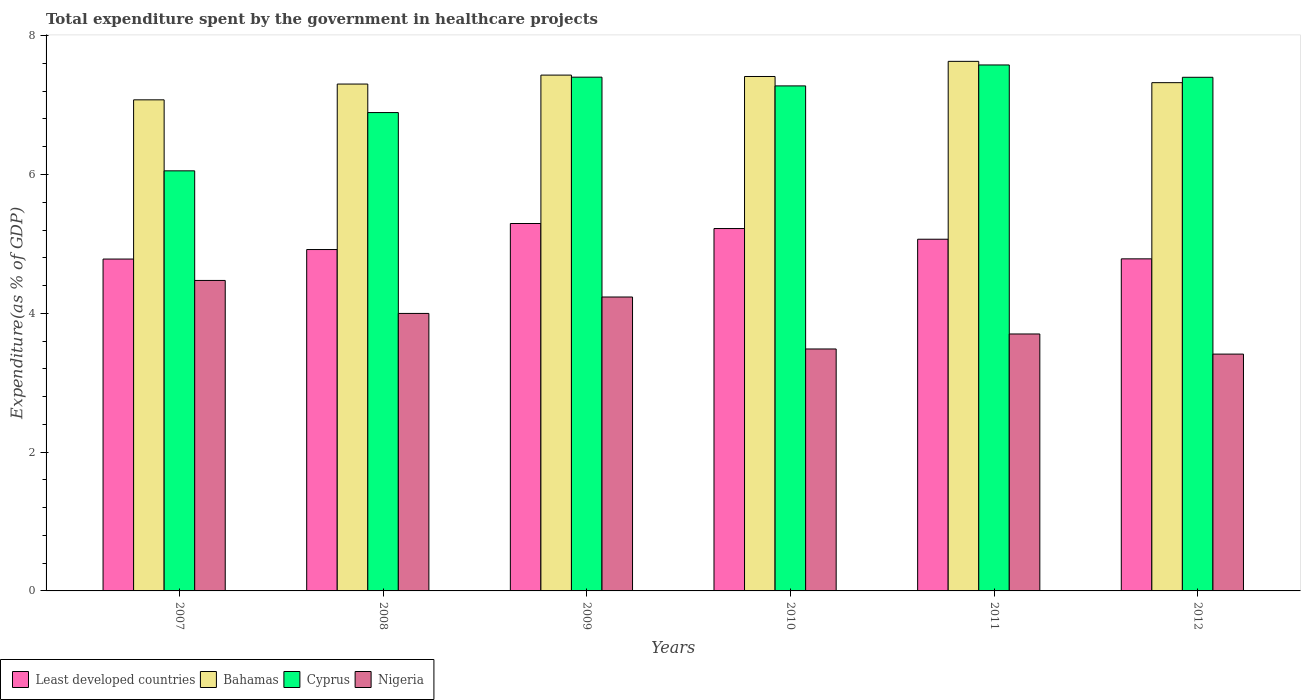How many different coloured bars are there?
Offer a very short reply. 4. How many bars are there on the 2nd tick from the right?
Give a very brief answer. 4. What is the label of the 6th group of bars from the left?
Ensure brevity in your answer.  2012. In how many cases, is the number of bars for a given year not equal to the number of legend labels?
Keep it short and to the point. 0. What is the total expenditure spent by the government in healthcare projects in Cyprus in 2010?
Ensure brevity in your answer.  7.28. Across all years, what is the maximum total expenditure spent by the government in healthcare projects in Nigeria?
Offer a terse response. 4.47. Across all years, what is the minimum total expenditure spent by the government in healthcare projects in Cyprus?
Your response must be concise. 6.05. In which year was the total expenditure spent by the government in healthcare projects in Least developed countries maximum?
Your answer should be very brief. 2009. In which year was the total expenditure spent by the government in healthcare projects in Cyprus minimum?
Offer a very short reply. 2007. What is the total total expenditure spent by the government in healthcare projects in Least developed countries in the graph?
Make the answer very short. 30.07. What is the difference between the total expenditure spent by the government in healthcare projects in Least developed countries in 2009 and that in 2010?
Offer a very short reply. 0.07. What is the difference between the total expenditure spent by the government in healthcare projects in Bahamas in 2007 and the total expenditure spent by the government in healthcare projects in Nigeria in 2012?
Ensure brevity in your answer.  3.66. What is the average total expenditure spent by the government in healthcare projects in Bahamas per year?
Keep it short and to the point. 7.36. In the year 2010, what is the difference between the total expenditure spent by the government in healthcare projects in Cyprus and total expenditure spent by the government in healthcare projects in Least developed countries?
Your answer should be very brief. 2.06. In how many years, is the total expenditure spent by the government in healthcare projects in Least developed countries greater than 2.4 %?
Offer a very short reply. 6. What is the ratio of the total expenditure spent by the government in healthcare projects in Bahamas in 2008 to that in 2012?
Give a very brief answer. 1. Is the total expenditure spent by the government in healthcare projects in Least developed countries in 2010 less than that in 2012?
Keep it short and to the point. No. What is the difference between the highest and the second highest total expenditure spent by the government in healthcare projects in Bahamas?
Your answer should be compact. 0.2. What is the difference between the highest and the lowest total expenditure spent by the government in healthcare projects in Bahamas?
Keep it short and to the point. 0.55. What does the 4th bar from the left in 2009 represents?
Provide a short and direct response. Nigeria. What does the 1st bar from the right in 2010 represents?
Give a very brief answer. Nigeria. Is it the case that in every year, the sum of the total expenditure spent by the government in healthcare projects in Nigeria and total expenditure spent by the government in healthcare projects in Cyprus is greater than the total expenditure spent by the government in healthcare projects in Bahamas?
Give a very brief answer. Yes. Are all the bars in the graph horizontal?
Your answer should be compact. No. Does the graph contain any zero values?
Provide a short and direct response. No. Where does the legend appear in the graph?
Keep it short and to the point. Bottom left. How many legend labels are there?
Ensure brevity in your answer.  4. How are the legend labels stacked?
Your answer should be very brief. Horizontal. What is the title of the graph?
Make the answer very short. Total expenditure spent by the government in healthcare projects. Does "Latin America(all income levels)" appear as one of the legend labels in the graph?
Your answer should be compact. No. What is the label or title of the Y-axis?
Offer a terse response. Expenditure(as % of GDP). What is the Expenditure(as % of GDP) in Least developed countries in 2007?
Offer a very short reply. 4.78. What is the Expenditure(as % of GDP) in Bahamas in 2007?
Your answer should be compact. 7.08. What is the Expenditure(as % of GDP) in Cyprus in 2007?
Ensure brevity in your answer.  6.05. What is the Expenditure(as % of GDP) in Nigeria in 2007?
Your response must be concise. 4.47. What is the Expenditure(as % of GDP) in Least developed countries in 2008?
Provide a short and direct response. 4.92. What is the Expenditure(as % of GDP) of Bahamas in 2008?
Keep it short and to the point. 7.3. What is the Expenditure(as % of GDP) of Cyprus in 2008?
Give a very brief answer. 6.89. What is the Expenditure(as % of GDP) in Nigeria in 2008?
Give a very brief answer. 4. What is the Expenditure(as % of GDP) in Least developed countries in 2009?
Offer a terse response. 5.29. What is the Expenditure(as % of GDP) in Bahamas in 2009?
Offer a very short reply. 7.43. What is the Expenditure(as % of GDP) in Cyprus in 2009?
Keep it short and to the point. 7.4. What is the Expenditure(as % of GDP) of Nigeria in 2009?
Your response must be concise. 4.23. What is the Expenditure(as % of GDP) in Least developed countries in 2010?
Keep it short and to the point. 5.22. What is the Expenditure(as % of GDP) in Bahamas in 2010?
Make the answer very short. 7.41. What is the Expenditure(as % of GDP) in Cyprus in 2010?
Provide a short and direct response. 7.28. What is the Expenditure(as % of GDP) of Nigeria in 2010?
Your answer should be very brief. 3.49. What is the Expenditure(as % of GDP) of Least developed countries in 2011?
Your response must be concise. 5.07. What is the Expenditure(as % of GDP) in Bahamas in 2011?
Keep it short and to the point. 7.63. What is the Expenditure(as % of GDP) in Cyprus in 2011?
Provide a succinct answer. 7.58. What is the Expenditure(as % of GDP) of Nigeria in 2011?
Provide a succinct answer. 3.7. What is the Expenditure(as % of GDP) of Least developed countries in 2012?
Offer a terse response. 4.78. What is the Expenditure(as % of GDP) of Bahamas in 2012?
Your response must be concise. 7.32. What is the Expenditure(as % of GDP) of Cyprus in 2012?
Provide a succinct answer. 7.4. What is the Expenditure(as % of GDP) of Nigeria in 2012?
Make the answer very short. 3.41. Across all years, what is the maximum Expenditure(as % of GDP) in Least developed countries?
Make the answer very short. 5.29. Across all years, what is the maximum Expenditure(as % of GDP) of Bahamas?
Make the answer very short. 7.63. Across all years, what is the maximum Expenditure(as % of GDP) in Cyprus?
Make the answer very short. 7.58. Across all years, what is the maximum Expenditure(as % of GDP) of Nigeria?
Offer a very short reply. 4.47. Across all years, what is the minimum Expenditure(as % of GDP) in Least developed countries?
Your answer should be very brief. 4.78. Across all years, what is the minimum Expenditure(as % of GDP) of Bahamas?
Keep it short and to the point. 7.08. Across all years, what is the minimum Expenditure(as % of GDP) of Cyprus?
Keep it short and to the point. 6.05. Across all years, what is the minimum Expenditure(as % of GDP) of Nigeria?
Make the answer very short. 3.41. What is the total Expenditure(as % of GDP) of Least developed countries in the graph?
Give a very brief answer. 30.07. What is the total Expenditure(as % of GDP) in Bahamas in the graph?
Ensure brevity in your answer.  44.18. What is the total Expenditure(as % of GDP) in Cyprus in the graph?
Provide a short and direct response. 42.6. What is the total Expenditure(as % of GDP) of Nigeria in the graph?
Offer a very short reply. 23.31. What is the difference between the Expenditure(as % of GDP) of Least developed countries in 2007 and that in 2008?
Give a very brief answer. -0.14. What is the difference between the Expenditure(as % of GDP) in Bahamas in 2007 and that in 2008?
Make the answer very short. -0.23. What is the difference between the Expenditure(as % of GDP) in Cyprus in 2007 and that in 2008?
Your answer should be compact. -0.84. What is the difference between the Expenditure(as % of GDP) in Nigeria in 2007 and that in 2008?
Offer a terse response. 0.48. What is the difference between the Expenditure(as % of GDP) in Least developed countries in 2007 and that in 2009?
Provide a succinct answer. -0.51. What is the difference between the Expenditure(as % of GDP) of Bahamas in 2007 and that in 2009?
Ensure brevity in your answer.  -0.36. What is the difference between the Expenditure(as % of GDP) of Cyprus in 2007 and that in 2009?
Keep it short and to the point. -1.35. What is the difference between the Expenditure(as % of GDP) of Nigeria in 2007 and that in 2009?
Provide a short and direct response. 0.24. What is the difference between the Expenditure(as % of GDP) in Least developed countries in 2007 and that in 2010?
Your response must be concise. -0.44. What is the difference between the Expenditure(as % of GDP) of Bahamas in 2007 and that in 2010?
Ensure brevity in your answer.  -0.34. What is the difference between the Expenditure(as % of GDP) in Cyprus in 2007 and that in 2010?
Offer a terse response. -1.22. What is the difference between the Expenditure(as % of GDP) of Nigeria in 2007 and that in 2010?
Provide a short and direct response. 0.99. What is the difference between the Expenditure(as % of GDP) in Least developed countries in 2007 and that in 2011?
Your response must be concise. -0.29. What is the difference between the Expenditure(as % of GDP) in Bahamas in 2007 and that in 2011?
Offer a very short reply. -0.55. What is the difference between the Expenditure(as % of GDP) in Cyprus in 2007 and that in 2011?
Provide a short and direct response. -1.53. What is the difference between the Expenditure(as % of GDP) of Nigeria in 2007 and that in 2011?
Your answer should be compact. 0.77. What is the difference between the Expenditure(as % of GDP) in Least developed countries in 2007 and that in 2012?
Keep it short and to the point. -0. What is the difference between the Expenditure(as % of GDP) of Bahamas in 2007 and that in 2012?
Offer a terse response. -0.25. What is the difference between the Expenditure(as % of GDP) in Cyprus in 2007 and that in 2012?
Offer a terse response. -1.35. What is the difference between the Expenditure(as % of GDP) in Nigeria in 2007 and that in 2012?
Make the answer very short. 1.06. What is the difference between the Expenditure(as % of GDP) in Least developed countries in 2008 and that in 2009?
Your response must be concise. -0.38. What is the difference between the Expenditure(as % of GDP) in Bahamas in 2008 and that in 2009?
Ensure brevity in your answer.  -0.13. What is the difference between the Expenditure(as % of GDP) in Cyprus in 2008 and that in 2009?
Ensure brevity in your answer.  -0.51. What is the difference between the Expenditure(as % of GDP) of Nigeria in 2008 and that in 2009?
Your response must be concise. -0.24. What is the difference between the Expenditure(as % of GDP) of Least developed countries in 2008 and that in 2010?
Your response must be concise. -0.3. What is the difference between the Expenditure(as % of GDP) of Bahamas in 2008 and that in 2010?
Give a very brief answer. -0.11. What is the difference between the Expenditure(as % of GDP) of Cyprus in 2008 and that in 2010?
Offer a terse response. -0.38. What is the difference between the Expenditure(as % of GDP) in Nigeria in 2008 and that in 2010?
Keep it short and to the point. 0.51. What is the difference between the Expenditure(as % of GDP) of Least developed countries in 2008 and that in 2011?
Your answer should be very brief. -0.15. What is the difference between the Expenditure(as % of GDP) of Bahamas in 2008 and that in 2011?
Give a very brief answer. -0.33. What is the difference between the Expenditure(as % of GDP) of Cyprus in 2008 and that in 2011?
Keep it short and to the point. -0.69. What is the difference between the Expenditure(as % of GDP) of Nigeria in 2008 and that in 2011?
Your response must be concise. 0.3. What is the difference between the Expenditure(as % of GDP) of Least developed countries in 2008 and that in 2012?
Give a very brief answer. 0.13. What is the difference between the Expenditure(as % of GDP) of Bahamas in 2008 and that in 2012?
Your answer should be very brief. -0.02. What is the difference between the Expenditure(as % of GDP) in Cyprus in 2008 and that in 2012?
Your response must be concise. -0.51. What is the difference between the Expenditure(as % of GDP) in Nigeria in 2008 and that in 2012?
Give a very brief answer. 0.59. What is the difference between the Expenditure(as % of GDP) of Least developed countries in 2009 and that in 2010?
Offer a very short reply. 0.07. What is the difference between the Expenditure(as % of GDP) of Bahamas in 2009 and that in 2010?
Your response must be concise. 0.02. What is the difference between the Expenditure(as % of GDP) in Cyprus in 2009 and that in 2010?
Provide a short and direct response. 0.13. What is the difference between the Expenditure(as % of GDP) of Nigeria in 2009 and that in 2010?
Provide a succinct answer. 0.75. What is the difference between the Expenditure(as % of GDP) of Least developed countries in 2009 and that in 2011?
Your answer should be very brief. 0.23. What is the difference between the Expenditure(as % of GDP) in Bahamas in 2009 and that in 2011?
Provide a succinct answer. -0.2. What is the difference between the Expenditure(as % of GDP) in Cyprus in 2009 and that in 2011?
Offer a very short reply. -0.18. What is the difference between the Expenditure(as % of GDP) of Nigeria in 2009 and that in 2011?
Offer a terse response. 0.53. What is the difference between the Expenditure(as % of GDP) of Least developed countries in 2009 and that in 2012?
Your answer should be compact. 0.51. What is the difference between the Expenditure(as % of GDP) of Bahamas in 2009 and that in 2012?
Your response must be concise. 0.11. What is the difference between the Expenditure(as % of GDP) in Cyprus in 2009 and that in 2012?
Ensure brevity in your answer.  0. What is the difference between the Expenditure(as % of GDP) of Nigeria in 2009 and that in 2012?
Offer a terse response. 0.82. What is the difference between the Expenditure(as % of GDP) of Least developed countries in 2010 and that in 2011?
Keep it short and to the point. 0.15. What is the difference between the Expenditure(as % of GDP) of Bahamas in 2010 and that in 2011?
Give a very brief answer. -0.22. What is the difference between the Expenditure(as % of GDP) in Cyprus in 2010 and that in 2011?
Offer a terse response. -0.3. What is the difference between the Expenditure(as % of GDP) in Nigeria in 2010 and that in 2011?
Provide a short and direct response. -0.22. What is the difference between the Expenditure(as % of GDP) in Least developed countries in 2010 and that in 2012?
Keep it short and to the point. 0.44. What is the difference between the Expenditure(as % of GDP) of Bahamas in 2010 and that in 2012?
Give a very brief answer. 0.09. What is the difference between the Expenditure(as % of GDP) in Cyprus in 2010 and that in 2012?
Your answer should be very brief. -0.12. What is the difference between the Expenditure(as % of GDP) in Nigeria in 2010 and that in 2012?
Provide a succinct answer. 0.07. What is the difference between the Expenditure(as % of GDP) of Least developed countries in 2011 and that in 2012?
Offer a terse response. 0.28. What is the difference between the Expenditure(as % of GDP) of Bahamas in 2011 and that in 2012?
Give a very brief answer. 0.31. What is the difference between the Expenditure(as % of GDP) of Cyprus in 2011 and that in 2012?
Offer a terse response. 0.18. What is the difference between the Expenditure(as % of GDP) of Nigeria in 2011 and that in 2012?
Your answer should be very brief. 0.29. What is the difference between the Expenditure(as % of GDP) in Least developed countries in 2007 and the Expenditure(as % of GDP) in Bahamas in 2008?
Offer a terse response. -2.52. What is the difference between the Expenditure(as % of GDP) of Least developed countries in 2007 and the Expenditure(as % of GDP) of Cyprus in 2008?
Provide a succinct answer. -2.11. What is the difference between the Expenditure(as % of GDP) in Least developed countries in 2007 and the Expenditure(as % of GDP) in Nigeria in 2008?
Your response must be concise. 0.78. What is the difference between the Expenditure(as % of GDP) of Bahamas in 2007 and the Expenditure(as % of GDP) of Cyprus in 2008?
Keep it short and to the point. 0.18. What is the difference between the Expenditure(as % of GDP) of Bahamas in 2007 and the Expenditure(as % of GDP) of Nigeria in 2008?
Provide a short and direct response. 3.08. What is the difference between the Expenditure(as % of GDP) in Cyprus in 2007 and the Expenditure(as % of GDP) in Nigeria in 2008?
Offer a very short reply. 2.05. What is the difference between the Expenditure(as % of GDP) in Least developed countries in 2007 and the Expenditure(as % of GDP) in Bahamas in 2009?
Make the answer very short. -2.65. What is the difference between the Expenditure(as % of GDP) of Least developed countries in 2007 and the Expenditure(as % of GDP) of Cyprus in 2009?
Your answer should be compact. -2.62. What is the difference between the Expenditure(as % of GDP) of Least developed countries in 2007 and the Expenditure(as % of GDP) of Nigeria in 2009?
Ensure brevity in your answer.  0.55. What is the difference between the Expenditure(as % of GDP) of Bahamas in 2007 and the Expenditure(as % of GDP) of Cyprus in 2009?
Ensure brevity in your answer.  -0.33. What is the difference between the Expenditure(as % of GDP) of Bahamas in 2007 and the Expenditure(as % of GDP) of Nigeria in 2009?
Your answer should be very brief. 2.84. What is the difference between the Expenditure(as % of GDP) of Cyprus in 2007 and the Expenditure(as % of GDP) of Nigeria in 2009?
Your response must be concise. 1.82. What is the difference between the Expenditure(as % of GDP) in Least developed countries in 2007 and the Expenditure(as % of GDP) in Bahamas in 2010?
Your answer should be compact. -2.63. What is the difference between the Expenditure(as % of GDP) of Least developed countries in 2007 and the Expenditure(as % of GDP) of Cyprus in 2010?
Keep it short and to the point. -2.5. What is the difference between the Expenditure(as % of GDP) in Least developed countries in 2007 and the Expenditure(as % of GDP) in Nigeria in 2010?
Your response must be concise. 1.3. What is the difference between the Expenditure(as % of GDP) of Bahamas in 2007 and the Expenditure(as % of GDP) of Cyprus in 2010?
Make the answer very short. -0.2. What is the difference between the Expenditure(as % of GDP) in Bahamas in 2007 and the Expenditure(as % of GDP) in Nigeria in 2010?
Offer a very short reply. 3.59. What is the difference between the Expenditure(as % of GDP) in Cyprus in 2007 and the Expenditure(as % of GDP) in Nigeria in 2010?
Provide a short and direct response. 2.57. What is the difference between the Expenditure(as % of GDP) of Least developed countries in 2007 and the Expenditure(as % of GDP) of Bahamas in 2011?
Your answer should be very brief. -2.85. What is the difference between the Expenditure(as % of GDP) in Least developed countries in 2007 and the Expenditure(as % of GDP) in Cyprus in 2011?
Your response must be concise. -2.8. What is the difference between the Expenditure(as % of GDP) in Least developed countries in 2007 and the Expenditure(as % of GDP) in Nigeria in 2011?
Provide a succinct answer. 1.08. What is the difference between the Expenditure(as % of GDP) of Bahamas in 2007 and the Expenditure(as % of GDP) of Cyprus in 2011?
Your answer should be compact. -0.5. What is the difference between the Expenditure(as % of GDP) in Bahamas in 2007 and the Expenditure(as % of GDP) in Nigeria in 2011?
Ensure brevity in your answer.  3.37. What is the difference between the Expenditure(as % of GDP) of Cyprus in 2007 and the Expenditure(as % of GDP) of Nigeria in 2011?
Your answer should be very brief. 2.35. What is the difference between the Expenditure(as % of GDP) of Least developed countries in 2007 and the Expenditure(as % of GDP) of Bahamas in 2012?
Your answer should be very brief. -2.54. What is the difference between the Expenditure(as % of GDP) in Least developed countries in 2007 and the Expenditure(as % of GDP) in Cyprus in 2012?
Your answer should be very brief. -2.62. What is the difference between the Expenditure(as % of GDP) of Least developed countries in 2007 and the Expenditure(as % of GDP) of Nigeria in 2012?
Your answer should be very brief. 1.37. What is the difference between the Expenditure(as % of GDP) of Bahamas in 2007 and the Expenditure(as % of GDP) of Cyprus in 2012?
Offer a very short reply. -0.32. What is the difference between the Expenditure(as % of GDP) in Bahamas in 2007 and the Expenditure(as % of GDP) in Nigeria in 2012?
Provide a short and direct response. 3.66. What is the difference between the Expenditure(as % of GDP) of Cyprus in 2007 and the Expenditure(as % of GDP) of Nigeria in 2012?
Make the answer very short. 2.64. What is the difference between the Expenditure(as % of GDP) of Least developed countries in 2008 and the Expenditure(as % of GDP) of Bahamas in 2009?
Provide a succinct answer. -2.51. What is the difference between the Expenditure(as % of GDP) in Least developed countries in 2008 and the Expenditure(as % of GDP) in Cyprus in 2009?
Make the answer very short. -2.48. What is the difference between the Expenditure(as % of GDP) of Least developed countries in 2008 and the Expenditure(as % of GDP) of Nigeria in 2009?
Your response must be concise. 0.68. What is the difference between the Expenditure(as % of GDP) in Bahamas in 2008 and the Expenditure(as % of GDP) in Cyprus in 2009?
Your answer should be very brief. -0.1. What is the difference between the Expenditure(as % of GDP) of Bahamas in 2008 and the Expenditure(as % of GDP) of Nigeria in 2009?
Provide a succinct answer. 3.07. What is the difference between the Expenditure(as % of GDP) in Cyprus in 2008 and the Expenditure(as % of GDP) in Nigeria in 2009?
Your answer should be compact. 2.66. What is the difference between the Expenditure(as % of GDP) of Least developed countries in 2008 and the Expenditure(as % of GDP) of Bahamas in 2010?
Make the answer very short. -2.49. What is the difference between the Expenditure(as % of GDP) of Least developed countries in 2008 and the Expenditure(as % of GDP) of Cyprus in 2010?
Your answer should be very brief. -2.36. What is the difference between the Expenditure(as % of GDP) in Least developed countries in 2008 and the Expenditure(as % of GDP) in Nigeria in 2010?
Provide a succinct answer. 1.43. What is the difference between the Expenditure(as % of GDP) of Bahamas in 2008 and the Expenditure(as % of GDP) of Cyprus in 2010?
Ensure brevity in your answer.  0.03. What is the difference between the Expenditure(as % of GDP) in Bahamas in 2008 and the Expenditure(as % of GDP) in Nigeria in 2010?
Provide a short and direct response. 3.82. What is the difference between the Expenditure(as % of GDP) of Cyprus in 2008 and the Expenditure(as % of GDP) of Nigeria in 2010?
Offer a very short reply. 3.41. What is the difference between the Expenditure(as % of GDP) of Least developed countries in 2008 and the Expenditure(as % of GDP) of Bahamas in 2011?
Offer a terse response. -2.71. What is the difference between the Expenditure(as % of GDP) of Least developed countries in 2008 and the Expenditure(as % of GDP) of Cyprus in 2011?
Provide a short and direct response. -2.66. What is the difference between the Expenditure(as % of GDP) in Least developed countries in 2008 and the Expenditure(as % of GDP) in Nigeria in 2011?
Your response must be concise. 1.22. What is the difference between the Expenditure(as % of GDP) in Bahamas in 2008 and the Expenditure(as % of GDP) in Cyprus in 2011?
Give a very brief answer. -0.28. What is the difference between the Expenditure(as % of GDP) in Bahamas in 2008 and the Expenditure(as % of GDP) in Nigeria in 2011?
Provide a short and direct response. 3.6. What is the difference between the Expenditure(as % of GDP) of Cyprus in 2008 and the Expenditure(as % of GDP) of Nigeria in 2011?
Give a very brief answer. 3.19. What is the difference between the Expenditure(as % of GDP) of Least developed countries in 2008 and the Expenditure(as % of GDP) of Bahamas in 2012?
Give a very brief answer. -2.4. What is the difference between the Expenditure(as % of GDP) of Least developed countries in 2008 and the Expenditure(as % of GDP) of Cyprus in 2012?
Make the answer very short. -2.48. What is the difference between the Expenditure(as % of GDP) of Least developed countries in 2008 and the Expenditure(as % of GDP) of Nigeria in 2012?
Offer a terse response. 1.51. What is the difference between the Expenditure(as % of GDP) of Bahamas in 2008 and the Expenditure(as % of GDP) of Cyprus in 2012?
Offer a terse response. -0.1. What is the difference between the Expenditure(as % of GDP) in Bahamas in 2008 and the Expenditure(as % of GDP) in Nigeria in 2012?
Give a very brief answer. 3.89. What is the difference between the Expenditure(as % of GDP) in Cyprus in 2008 and the Expenditure(as % of GDP) in Nigeria in 2012?
Provide a succinct answer. 3.48. What is the difference between the Expenditure(as % of GDP) in Least developed countries in 2009 and the Expenditure(as % of GDP) in Bahamas in 2010?
Your answer should be very brief. -2.12. What is the difference between the Expenditure(as % of GDP) in Least developed countries in 2009 and the Expenditure(as % of GDP) in Cyprus in 2010?
Provide a succinct answer. -1.98. What is the difference between the Expenditure(as % of GDP) in Least developed countries in 2009 and the Expenditure(as % of GDP) in Nigeria in 2010?
Provide a succinct answer. 1.81. What is the difference between the Expenditure(as % of GDP) in Bahamas in 2009 and the Expenditure(as % of GDP) in Cyprus in 2010?
Give a very brief answer. 0.16. What is the difference between the Expenditure(as % of GDP) of Bahamas in 2009 and the Expenditure(as % of GDP) of Nigeria in 2010?
Your response must be concise. 3.95. What is the difference between the Expenditure(as % of GDP) in Cyprus in 2009 and the Expenditure(as % of GDP) in Nigeria in 2010?
Provide a succinct answer. 3.92. What is the difference between the Expenditure(as % of GDP) in Least developed countries in 2009 and the Expenditure(as % of GDP) in Bahamas in 2011?
Offer a terse response. -2.34. What is the difference between the Expenditure(as % of GDP) of Least developed countries in 2009 and the Expenditure(as % of GDP) of Cyprus in 2011?
Your answer should be compact. -2.28. What is the difference between the Expenditure(as % of GDP) of Least developed countries in 2009 and the Expenditure(as % of GDP) of Nigeria in 2011?
Give a very brief answer. 1.59. What is the difference between the Expenditure(as % of GDP) of Bahamas in 2009 and the Expenditure(as % of GDP) of Cyprus in 2011?
Your answer should be very brief. -0.15. What is the difference between the Expenditure(as % of GDP) of Bahamas in 2009 and the Expenditure(as % of GDP) of Nigeria in 2011?
Keep it short and to the point. 3.73. What is the difference between the Expenditure(as % of GDP) in Cyprus in 2009 and the Expenditure(as % of GDP) in Nigeria in 2011?
Your response must be concise. 3.7. What is the difference between the Expenditure(as % of GDP) of Least developed countries in 2009 and the Expenditure(as % of GDP) of Bahamas in 2012?
Provide a short and direct response. -2.03. What is the difference between the Expenditure(as % of GDP) in Least developed countries in 2009 and the Expenditure(as % of GDP) in Cyprus in 2012?
Ensure brevity in your answer.  -2.11. What is the difference between the Expenditure(as % of GDP) in Least developed countries in 2009 and the Expenditure(as % of GDP) in Nigeria in 2012?
Your answer should be very brief. 1.88. What is the difference between the Expenditure(as % of GDP) in Bahamas in 2009 and the Expenditure(as % of GDP) in Cyprus in 2012?
Provide a short and direct response. 0.03. What is the difference between the Expenditure(as % of GDP) of Bahamas in 2009 and the Expenditure(as % of GDP) of Nigeria in 2012?
Offer a terse response. 4.02. What is the difference between the Expenditure(as % of GDP) in Cyprus in 2009 and the Expenditure(as % of GDP) in Nigeria in 2012?
Ensure brevity in your answer.  3.99. What is the difference between the Expenditure(as % of GDP) in Least developed countries in 2010 and the Expenditure(as % of GDP) in Bahamas in 2011?
Keep it short and to the point. -2.41. What is the difference between the Expenditure(as % of GDP) in Least developed countries in 2010 and the Expenditure(as % of GDP) in Cyprus in 2011?
Your answer should be very brief. -2.36. What is the difference between the Expenditure(as % of GDP) of Least developed countries in 2010 and the Expenditure(as % of GDP) of Nigeria in 2011?
Give a very brief answer. 1.52. What is the difference between the Expenditure(as % of GDP) of Bahamas in 2010 and the Expenditure(as % of GDP) of Cyprus in 2011?
Your response must be concise. -0.17. What is the difference between the Expenditure(as % of GDP) in Bahamas in 2010 and the Expenditure(as % of GDP) in Nigeria in 2011?
Your response must be concise. 3.71. What is the difference between the Expenditure(as % of GDP) of Cyprus in 2010 and the Expenditure(as % of GDP) of Nigeria in 2011?
Your answer should be compact. 3.57. What is the difference between the Expenditure(as % of GDP) of Least developed countries in 2010 and the Expenditure(as % of GDP) of Bahamas in 2012?
Offer a very short reply. -2.1. What is the difference between the Expenditure(as % of GDP) of Least developed countries in 2010 and the Expenditure(as % of GDP) of Cyprus in 2012?
Your answer should be very brief. -2.18. What is the difference between the Expenditure(as % of GDP) in Least developed countries in 2010 and the Expenditure(as % of GDP) in Nigeria in 2012?
Offer a terse response. 1.81. What is the difference between the Expenditure(as % of GDP) of Bahamas in 2010 and the Expenditure(as % of GDP) of Cyprus in 2012?
Ensure brevity in your answer.  0.01. What is the difference between the Expenditure(as % of GDP) of Bahamas in 2010 and the Expenditure(as % of GDP) of Nigeria in 2012?
Your answer should be compact. 4. What is the difference between the Expenditure(as % of GDP) of Cyprus in 2010 and the Expenditure(as % of GDP) of Nigeria in 2012?
Offer a very short reply. 3.86. What is the difference between the Expenditure(as % of GDP) of Least developed countries in 2011 and the Expenditure(as % of GDP) of Bahamas in 2012?
Your answer should be very brief. -2.26. What is the difference between the Expenditure(as % of GDP) of Least developed countries in 2011 and the Expenditure(as % of GDP) of Cyprus in 2012?
Offer a very short reply. -2.33. What is the difference between the Expenditure(as % of GDP) in Least developed countries in 2011 and the Expenditure(as % of GDP) in Nigeria in 2012?
Offer a very short reply. 1.66. What is the difference between the Expenditure(as % of GDP) in Bahamas in 2011 and the Expenditure(as % of GDP) in Cyprus in 2012?
Your answer should be very brief. 0.23. What is the difference between the Expenditure(as % of GDP) in Bahamas in 2011 and the Expenditure(as % of GDP) in Nigeria in 2012?
Your answer should be very brief. 4.22. What is the difference between the Expenditure(as % of GDP) in Cyprus in 2011 and the Expenditure(as % of GDP) in Nigeria in 2012?
Ensure brevity in your answer.  4.17. What is the average Expenditure(as % of GDP) in Least developed countries per year?
Your response must be concise. 5.01. What is the average Expenditure(as % of GDP) in Bahamas per year?
Ensure brevity in your answer.  7.36. What is the average Expenditure(as % of GDP) in Cyprus per year?
Your response must be concise. 7.1. What is the average Expenditure(as % of GDP) in Nigeria per year?
Your response must be concise. 3.88. In the year 2007, what is the difference between the Expenditure(as % of GDP) of Least developed countries and Expenditure(as % of GDP) of Bahamas?
Your response must be concise. -2.29. In the year 2007, what is the difference between the Expenditure(as % of GDP) in Least developed countries and Expenditure(as % of GDP) in Cyprus?
Your response must be concise. -1.27. In the year 2007, what is the difference between the Expenditure(as % of GDP) in Least developed countries and Expenditure(as % of GDP) in Nigeria?
Make the answer very short. 0.31. In the year 2007, what is the difference between the Expenditure(as % of GDP) in Bahamas and Expenditure(as % of GDP) in Cyprus?
Offer a very short reply. 1.02. In the year 2007, what is the difference between the Expenditure(as % of GDP) in Bahamas and Expenditure(as % of GDP) in Nigeria?
Keep it short and to the point. 2.6. In the year 2007, what is the difference between the Expenditure(as % of GDP) of Cyprus and Expenditure(as % of GDP) of Nigeria?
Your answer should be very brief. 1.58. In the year 2008, what is the difference between the Expenditure(as % of GDP) of Least developed countries and Expenditure(as % of GDP) of Bahamas?
Ensure brevity in your answer.  -2.38. In the year 2008, what is the difference between the Expenditure(as % of GDP) of Least developed countries and Expenditure(as % of GDP) of Cyprus?
Your response must be concise. -1.97. In the year 2008, what is the difference between the Expenditure(as % of GDP) of Least developed countries and Expenditure(as % of GDP) of Nigeria?
Your answer should be very brief. 0.92. In the year 2008, what is the difference between the Expenditure(as % of GDP) of Bahamas and Expenditure(as % of GDP) of Cyprus?
Your answer should be very brief. 0.41. In the year 2008, what is the difference between the Expenditure(as % of GDP) of Bahamas and Expenditure(as % of GDP) of Nigeria?
Ensure brevity in your answer.  3.3. In the year 2008, what is the difference between the Expenditure(as % of GDP) in Cyprus and Expenditure(as % of GDP) in Nigeria?
Offer a terse response. 2.89. In the year 2009, what is the difference between the Expenditure(as % of GDP) in Least developed countries and Expenditure(as % of GDP) in Bahamas?
Offer a terse response. -2.14. In the year 2009, what is the difference between the Expenditure(as % of GDP) in Least developed countries and Expenditure(as % of GDP) in Cyprus?
Ensure brevity in your answer.  -2.11. In the year 2009, what is the difference between the Expenditure(as % of GDP) of Least developed countries and Expenditure(as % of GDP) of Nigeria?
Offer a very short reply. 1.06. In the year 2009, what is the difference between the Expenditure(as % of GDP) in Bahamas and Expenditure(as % of GDP) in Cyprus?
Provide a succinct answer. 0.03. In the year 2009, what is the difference between the Expenditure(as % of GDP) in Bahamas and Expenditure(as % of GDP) in Nigeria?
Provide a short and direct response. 3.2. In the year 2009, what is the difference between the Expenditure(as % of GDP) of Cyprus and Expenditure(as % of GDP) of Nigeria?
Ensure brevity in your answer.  3.17. In the year 2010, what is the difference between the Expenditure(as % of GDP) in Least developed countries and Expenditure(as % of GDP) in Bahamas?
Your answer should be very brief. -2.19. In the year 2010, what is the difference between the Expenditure(as % of GDP) in Least developed countries and Expenditure(as % of GDP) in Cyprus?
Keep it short and to the point. -2.06. In the year 2010, what is the difference between the Expenditure(as % of GDP) in Least developed countries and Expenditure(as % of GDP) in Nigeria?
Your answer should be compact. 1.74. In the year 2010, what is the difference between the Expenditure(as % of GDP) in Bahamas and Expenditure(as % of GDP) in Cyprus?
Offer a very short reply. 0.14. In the year 2010, what is the difference between the Expenditure(as % of GDP) of Bahamas and Expenditure(as % of GDP) of Nigeria?
Your answer should be compact. 3.93. In the year 2010, what is the difference between the Expenditure(as % of GDP) in Cyprus and Expenditure(as % of GDP) in Nigeria?
Provide a short and direct response. 3.79. In the year 2011, what is the difference between the Expenditure(as % of GDP) of Least developed countries and Expenditure(as % of GDP) of Bahamas?
Your answer should be compact. -2.56. In the year 2011, what is the difference between the Expenditure(as % of GDP) of Least developed countries and Expenditure(as % of GDP) of Cyprus?
Give a very brief answer. -2.51. In the year 2011, what is the difference between the Expenditure(as % of GDP) in Least developed countries and Expenditure(as % of GDP) in Nigeria?
Make the answer very short. 1.37. In the year 2011, what is the difference between the Expenditure(as % of GDP) in Bahamas and Expenditure(as % of GDP) in Cyprus?
Keep it short and to the point. 0.05. In the year 2011, what is the difference between the Expenditure(as % of GDP) of Bahamas and Expenditure(as % of GDP) of Nigeria?
Offer a terse response. 3.93. In the year 2011, what is the difference between the Expenditure(as % of GDP) of Cyprus and Expenditure(as % of GDP) of Nigeria?
Provide a short and direct response. 3.88. In the year 2012, what is the difference between the Expenditure(as % of GDP) of Least developed countries and Expenditure(as % of GDP) of Bahamas?
Your response must be concise. -2.54. In the year 2012, what is the difference between the Expenditure(as % of GDP) of Least developed countries and Expenditure(as % of GDP) of Cyprus?
Give a very brief answer. -2.62. In the year 2012, what is the difference between the Expenditure(as % of GDP) in Least developed countries and Expenditure(as % of GDP) in Nigeria?
Offer a terse response. 1.37. In the year 2012, what is the difference between the Expenditure(as % of GDP) of Bahamas and Expenditure(as % of GDP) of Cyprus?
Provide a succinct answer. -0.08. In the year 2012, what is the difference between the Expenditure(as % of GDP) in Bahamas and Expenditure(as % of GDP) in Nigeria?
Make the answer very short. 3.91. In the year 2012, what is the difference between the Expenditure(as % of GDP) in Cyprus and Expenditure(as % of GDP) in Nigeria?
Ensure brevity in your answer.  3.99. What is the ratio of the Expenditure(as % of GDP) in Least developed countries in 2007 to that in 2008?
Provide a succinct answer. 0.97. What is the ratio of the Expenditure(as % of GDP) in Bahamas in 2007 to that in 2008?
Give a very brief answer. 0.97. What is the ratio of the Expenditure(as % of GDP) of Cyprus in 2007 to that in 2008?
Make the answer very short. 0.88. What is the ratio of the Expenditure(as % of GDP) in Nigeria in 2007 to that in 2008?
Provide a succinct answer. 1.12. What is the ratio of the Expenditure(as % of GDP) of Least developed countries in 2007 to that in 2009?
Your answer should be compact. 0.9. What is the ratio of the Expenditure(as % of GDP) of Bahamas in 2007 to that in 2009?
Ensure brevity in your answer.  0.95. What is the ratio of the Expenditure(as % of GDP) of Cyprus in 2007 to that in 2009?
Your answer should be very brief. 0.82. What is the ratio of the Expenditure(as % of GDP) in Nigeria in 2007 to that in 2009?
Make the answer very short. 1.06. What is the ratio of the Expenditure(as % of GDP) of Least developed countries in 2007 to that in 2010?
Your answer should be very brief. 0.92. What is the ratio of the Expenditure(as % of GDP) of Bahamas in 2007 to that in 2010?
Provide a short and direct response. 0.95. What is the ratio of the Expenditure(as % of GDP) of Cyprus in 2007 to that in 2010?
Make the answer very short. 0.83. What is the ratio of the Expenditure(as % of GDP) of Nigeria in 2007 to that in 2010?
Your response must be concise. 1.28. What is the ratio of the Expenditure(as % of GDP) in Least developed countries in 2007 to that in 2011?
Provide a short and direct response. 0.94. What is the ratio of the Expenditure(as % of GDP) in Bahamas in 2007 to that in 2011?
Ensure brevity in your answer.  0.93. What is the ratio of the Expenditure(as % of GDP) in Cyprus in 2007 to that in 2011?
Make the answer very short. 0.8. What is the ratio of the Expenditure(as % of GDP) in Nigeria in 2007 to that in 2011?
Your response must be concise. 1.21. What is the ratio of the Expenditure(as % of GDP) in Least developed countries in 2007 to that in 2012?
Make the answer very short. 1. What is the ratio of the Expenditure(as % of GDP) of Bahamas in 2007 to that in 2012?
Your answer should be compact. 0.97. What is the ratio of the Expenditure(as % of GDP) of Cyprus in 2007 to that in 2012?
Make the answer very short. 0.82. What is the ratio of the Expenditure(as % of GDP) of Nigeria in 2007 to that in 2012?
Give a very brief answer. 1.31. What is the ratio of the Expenditure(as % of GDP) of Least developed countries in 2008 to that in 2009?
Provide a short and direct response. 0.93. What is the ratio of the Expenditure(as % of GDP) in Bahamas in 2008 to that in 2009?
Provide a succinct answer. 0.98. What is the ratio of the Expenditure(as % of GDP) in Cyprus in 2008 to that in 2009?
Your response must be concise. 0.93. What is the ratio of the Expenditure(as % of GDP) in Nigeria in 2008 to that in 2009?
Your answer should be compact. 0.94. What is the ratio of the Expenditure(as % of GDP) in Least developed countries in 2008 to that in 2010?
Keep it short and to the point. 0.94. What is the ratio of the Expenditure(as % of GDP) of Bahamas in 2008 to that in 2010?
Give a very brief answer. 0.99. What is the ratio of the Expenditure(as % of GDP) in Cyprus in 2008 to that in 2010?
Offer a very short reply. 0.95. What is the ratio of the Expenditure(as % of GDP) of Nigeria in 2008 to that in 2010?
Offer a very short reply. 1.15. What is the ratio of the Expenditure(as % of GDP) of Least developed countries in 2008 to that in 2011?
Your answer should be compact. 0.97. What is the ratio of the Expenditure(as % of GDP) of Bahamas in 2008 to that in 2011?
Make the answer very short. 0.96. What is the ratio of the Expenditure(as % of GDP) of Cyprus in 2008 to that in 2011?
Provide a short and direct response. 0.91. What is the ratio of the Expenditure(as % of GDP) in Least developed countries in 2008 to that in 2012?
Offer a very short reply. 1.03. What is the ratio of the Expenditure(as % of GDP) of Cyprus in 2008 to that in 2012?
Make the answer very short. 0.93. What is the ratio of the Expenditure(as % of GDP) in Nigeria in 2008 to that in 2012?
Your answer should be compact. 1.17. What is the ratio of the Expenditure(as % of GDP) in Least developed countries in 2009 to that in 2010?
Keep it short and to the point. 1.01. What is the ratio of the Expenditure(as % of GDP) in Cyprus in 2009 to that in 2010?
Your response must be concise. 1.02. What is the ratio of the Expenditure(as % of GDP) of Nigeria in 2009 to that in 2010?
Provide a short and direct response. 1.21. What is the ratio of the Expenditure(as % of GDP) in Least developed countries in 2009 to that in 2011?
Offer a very short reply. 1.04. What is the ratio of the Expenditure(as % of GDP) in Bahamas in 2009 to that in 2011?
Your answer should be very brief. 0.97. What is the ratio of the Expenditure(as % of GDP) of Cyprus in 2009 to that in 2011?
Your answer should be very brief. 0.98. What is the ratio of the Expenditure(as % of GDP) in Nigeria in 2009 to that in 2011?
Offer a terse response. 1.14. What is the ratio of the Expenditure(as % of GDP) in Least developed countries in 2009 to that in 2012?
Offer a very short reply. 1.11. What is the ratio of the Expenditure(as % of GDP) of Bahamas in 2009 to that in 2012?
Your response must be concise. 1.01. What is the ratio of the Expenditure(as % of GDP) in Nigeria in 2009 to that in 2012?
Offer a very short reply. 1.24. What is the ratio of the Expenditure(as % of GDP) in Least developed countries in 2010 to that in 2011?
Keep it short and to the point. 1.03. What is the ratio of the Expenditure(as % of GDP) in Bahamas in 2010 to that in 2011?
Keep it short and to the point. 0.97. What is the ratio of the Expenditure(as % of GDP) of Cyprus in 2010 to that in 2011?
Offer a very short reply. 0.96. What is the ratio of the Expenditure(as % of GDP) in Nigeria in 2010 to that in 2011?
Offer a very short reply. 0.94. What is the ratio of the Expenditure(as % of GDP) in Least developed countries in 2010 to that in 2012?
Your answer should be compact. 1.09. What is the ratio of the Expenditure(as % of GDP) in Bahamas in 2010 to that in 2012?
Keep it short and to the point. 1.01. What is the ratio of the Expenditure(as % of GDP) of Cyprus in 2010 to that in 2012?
Ensure brevity in your answer.  0.98. What is the ratio of the Expenditure(as % of GDP) in Nigeria in 2010 to that in 2012?
Your response must be concise. 1.02. What is the ratio of the Expenditure(as % of GDP) of Least developed countries in 2011 to that in 2012?
Make the answer very short. 1.06. What is the ratio of the Expenditure(as % of GDP) in Bahamas in 2011 to that in 2012?
Your response must be concise. 1.04. What is the ratio of the Expenditure(as % of GDP) in Cyprus in 2011 to that in 2012?
Your response must be concise. 1.02. What is the ratio of the Expenditure(as % of GDP) in Nigeria in 2011 to that in 2012?
Ensure brevity in your answer.  1.08. What is the difference between the highest and the second highest Expenditure(as % of GDP) in Least developed countries?
Your answer should be compact. 0.07. What is the difference between the highest and the second highest Expenditure(as % of GDP) of Bahamas?
Provide a short and direct response. 0.2. What is the difference between the highest and the second highest Expenditure(as % of GDP) in Cyprus?
Ensure brevity in your answer.  0.18. What is the difference between the highest and the second highest Expenditure(as % of GDP) in Nigeria?
Give a very brief answer. 0.24. What is the difference between the highest and the lowest Expenditure(as % of GDP) in Least developed countries?
Your answer should be compact. 0.51. What is the difference between the highest and the lowest Expenditure(as % of GDP) of Bahamas?
Provide a succinct answer. 0.55. What is the difference between the highest and the lowest Expenditure(as % of GDP) in Cyprus?
Provide a succinct answer. 1.53. What is the difference between the highest and the lowest Expenditure(as % of GDP) in Nigeria?
Make the answer very short. 1.06. 